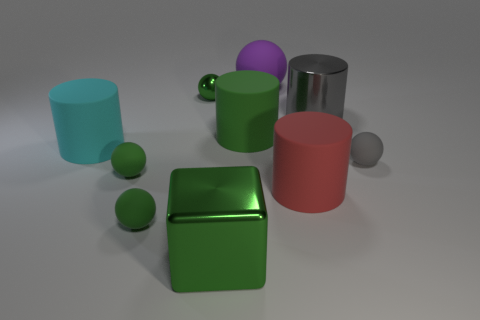Is there any other thing that has the same shape as the big green metallic thing?
Your answer should be very brief. No. Are there any tiny purple metallic objects of the same shape as the small gray rubber thing?
Make the answer very short. No. Are there any red rubber cylinders on the left side of the shiny object behind the gray thing that is behind the large cyan thing?
Offer a very short reply. No. Are there more objects behind the big green metallic block than large red things that are behind the large matte ball?
Provide a succinct answer. Yes. There is a red thing that is the same size as the metallic cylinder; what is it made of?
Provide a short and direct response. Rubber. How many big objects are yellow metallic things or balls?
Offer a very short reply. 1. Is the large cyan object the same shape as the red matte object?
Your response must be concise. Yes. What number of spheres are behind the tiny gray rubber thing and right of the red matte cylinder?
Give a very brief answer. 0. Is there any other thing that has the same color as the block?
Your response must be concise. Yes. There is a big purple object that is the same material as the small gray object; what is its shape?
Give a very brief answer. Sphere. 